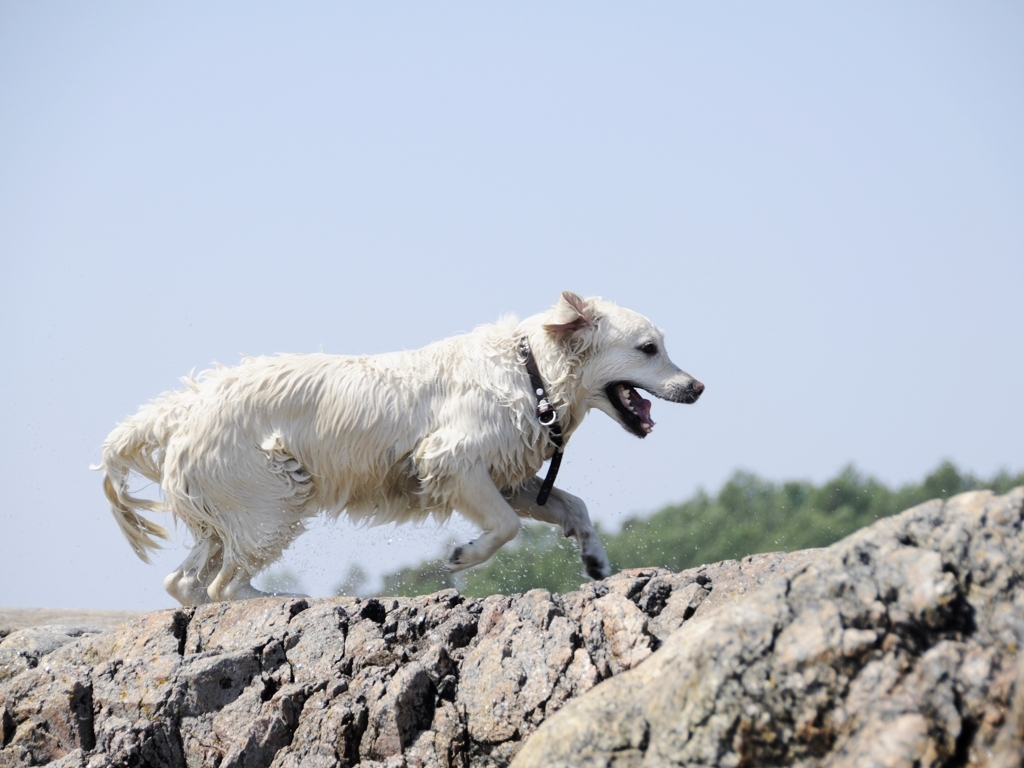What breed of dog is shown in the image? Based on the physical characteristics present in the image, the dog appears to be a Golden Retriever, known for their dense, water-repellent cream to golden coat. However, without further context or confirmation, this remains an educated guess based on visual assessment. Can you tell if the dog is engaged in a specific activity? Certainly! The dog appears to be in the midst of an energetic run, perhaps playing or exercising. Its joyful expression, open mouth, and position of its ears and tail suggest that it is having a good time, likely on a beach or an outdoor area with access to water. 